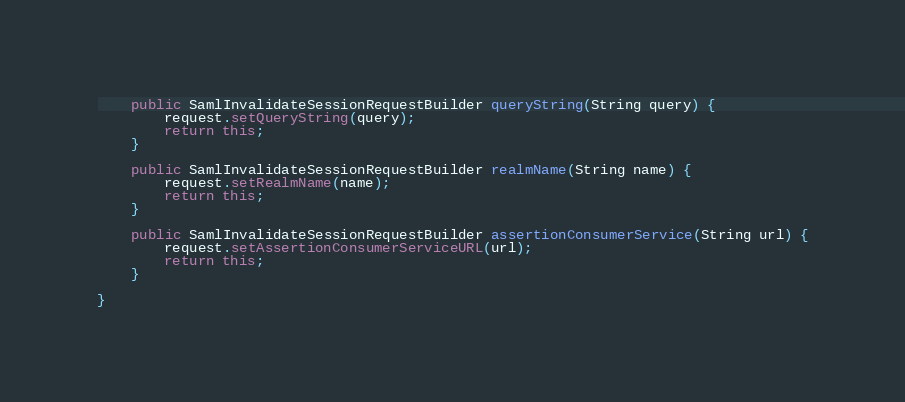<code> <loc_0><loc_0><loc_500><loc_500><_Java_>
    public SamlInvalidateSessionRequestBuilder queryString(String query) {
        request.setQueryString(query);
        return this;
    }

    public SamlInvalidateSessionRequestBuilder realmName(String name) {
        request.setRealmName(name);
        return this;
    }

    public SamlInvalidateSessionRequestBuilder assertionConsumerService(String url) {
        request.setAssertionConsumerServiceURL(url);
        return this;
    }

}
</code> 